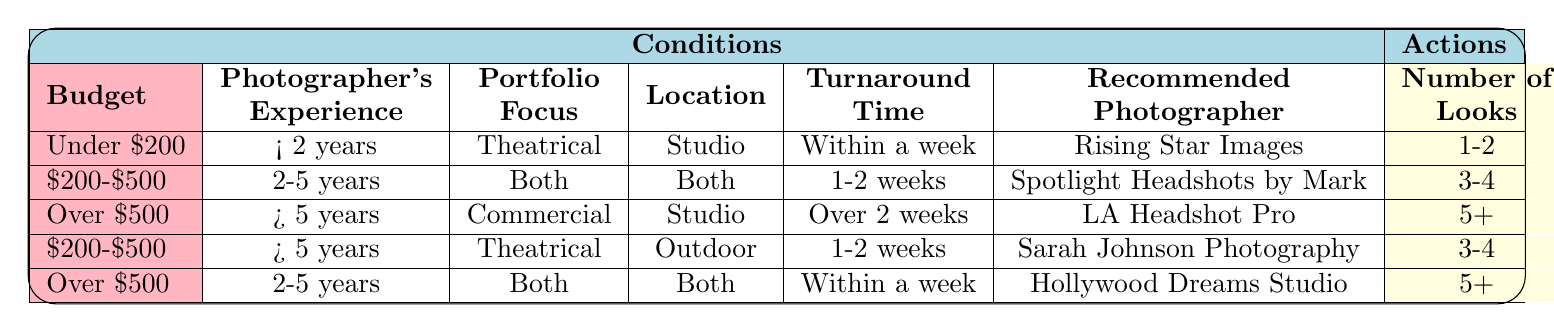What is the recommended photographer for a budget over $500 and 2-5 years of experience? In the table, I look for the row where the budget is "Over $500" and the photographer's experience is "2-5 years." I find this matches the fourth row, which recommends "Hollywood Dreams Studio."
Answer: Hollywood Dreams Studio What is the number of looks included if you choose Spotlight Headshots by Mark? I find the row corresponding to "Spotlight Headshots by Mark," which is in the second row. There, it specifies the number of looks as "3-4."
Answer: 3-4 Is retouching included when the budget is under $200? I check the row with the "Under $200" budget, which is the first row. It shows that retouching included is "Basic." Thus, retouching is indeed included.
Answer: Yes What is the average number of looks provided for a budget of $200-$500? I find two rows that fit the "Budget $200-$500" condition. The second row has "3-4" looks and the fourth row has "3-4" as well. To find the average, I note both values can be treated as 3.5 for average purposes. So, (3.5 + 3.5) / 2 = 3.5.
Answer: 3.5 Which photographer is recommended for those needing a theatrical focus and within a week turnaround time? I look for the conditions of "Theatrical" focus and "Within a week" turnaround time. This matches the first row, which recommends "Rising Star Images."
Answer: Rising Star Images Do any of the photographers provide digital files when the budget is over $500? I examine the rows with the "Over $500" budget and see that both photographers listed (LA Headshot Pro and Hollywood Dreams Studio) provide digital files, as both rows indicate "Yes" for that condition.
Answer: Yes What is the location choice for the photographer who offers advanced retouching and requires a turnaround of 1-2 weeks? The relevant condition based on the table is found in the second row (Spotlight Headshots by Mark) that indicates both location options are valid: "Both."
Answer: Both What is the recommended photographer for a budget under $200 and less than 2 years of experience? I locate the row where the budget is "Under $200" and the experience is "Less than 2 years." This leads me to the first row, which recommends "Rising Star Images."
Answer: Rising Star Images 